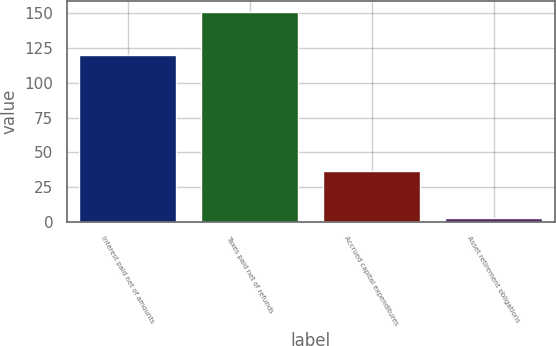<chart> <loc_0><loc_0><loc_500><loc_500><bar_chart><fcel>Interest paid net of amounts<fcel>Taxes paid net of refunds<fcel>Accrued capital expenditures<fcel>Asset retirement obligations<nl><fcel>120<fcel>151<fcel>37<fcel>3<nl></chart> 